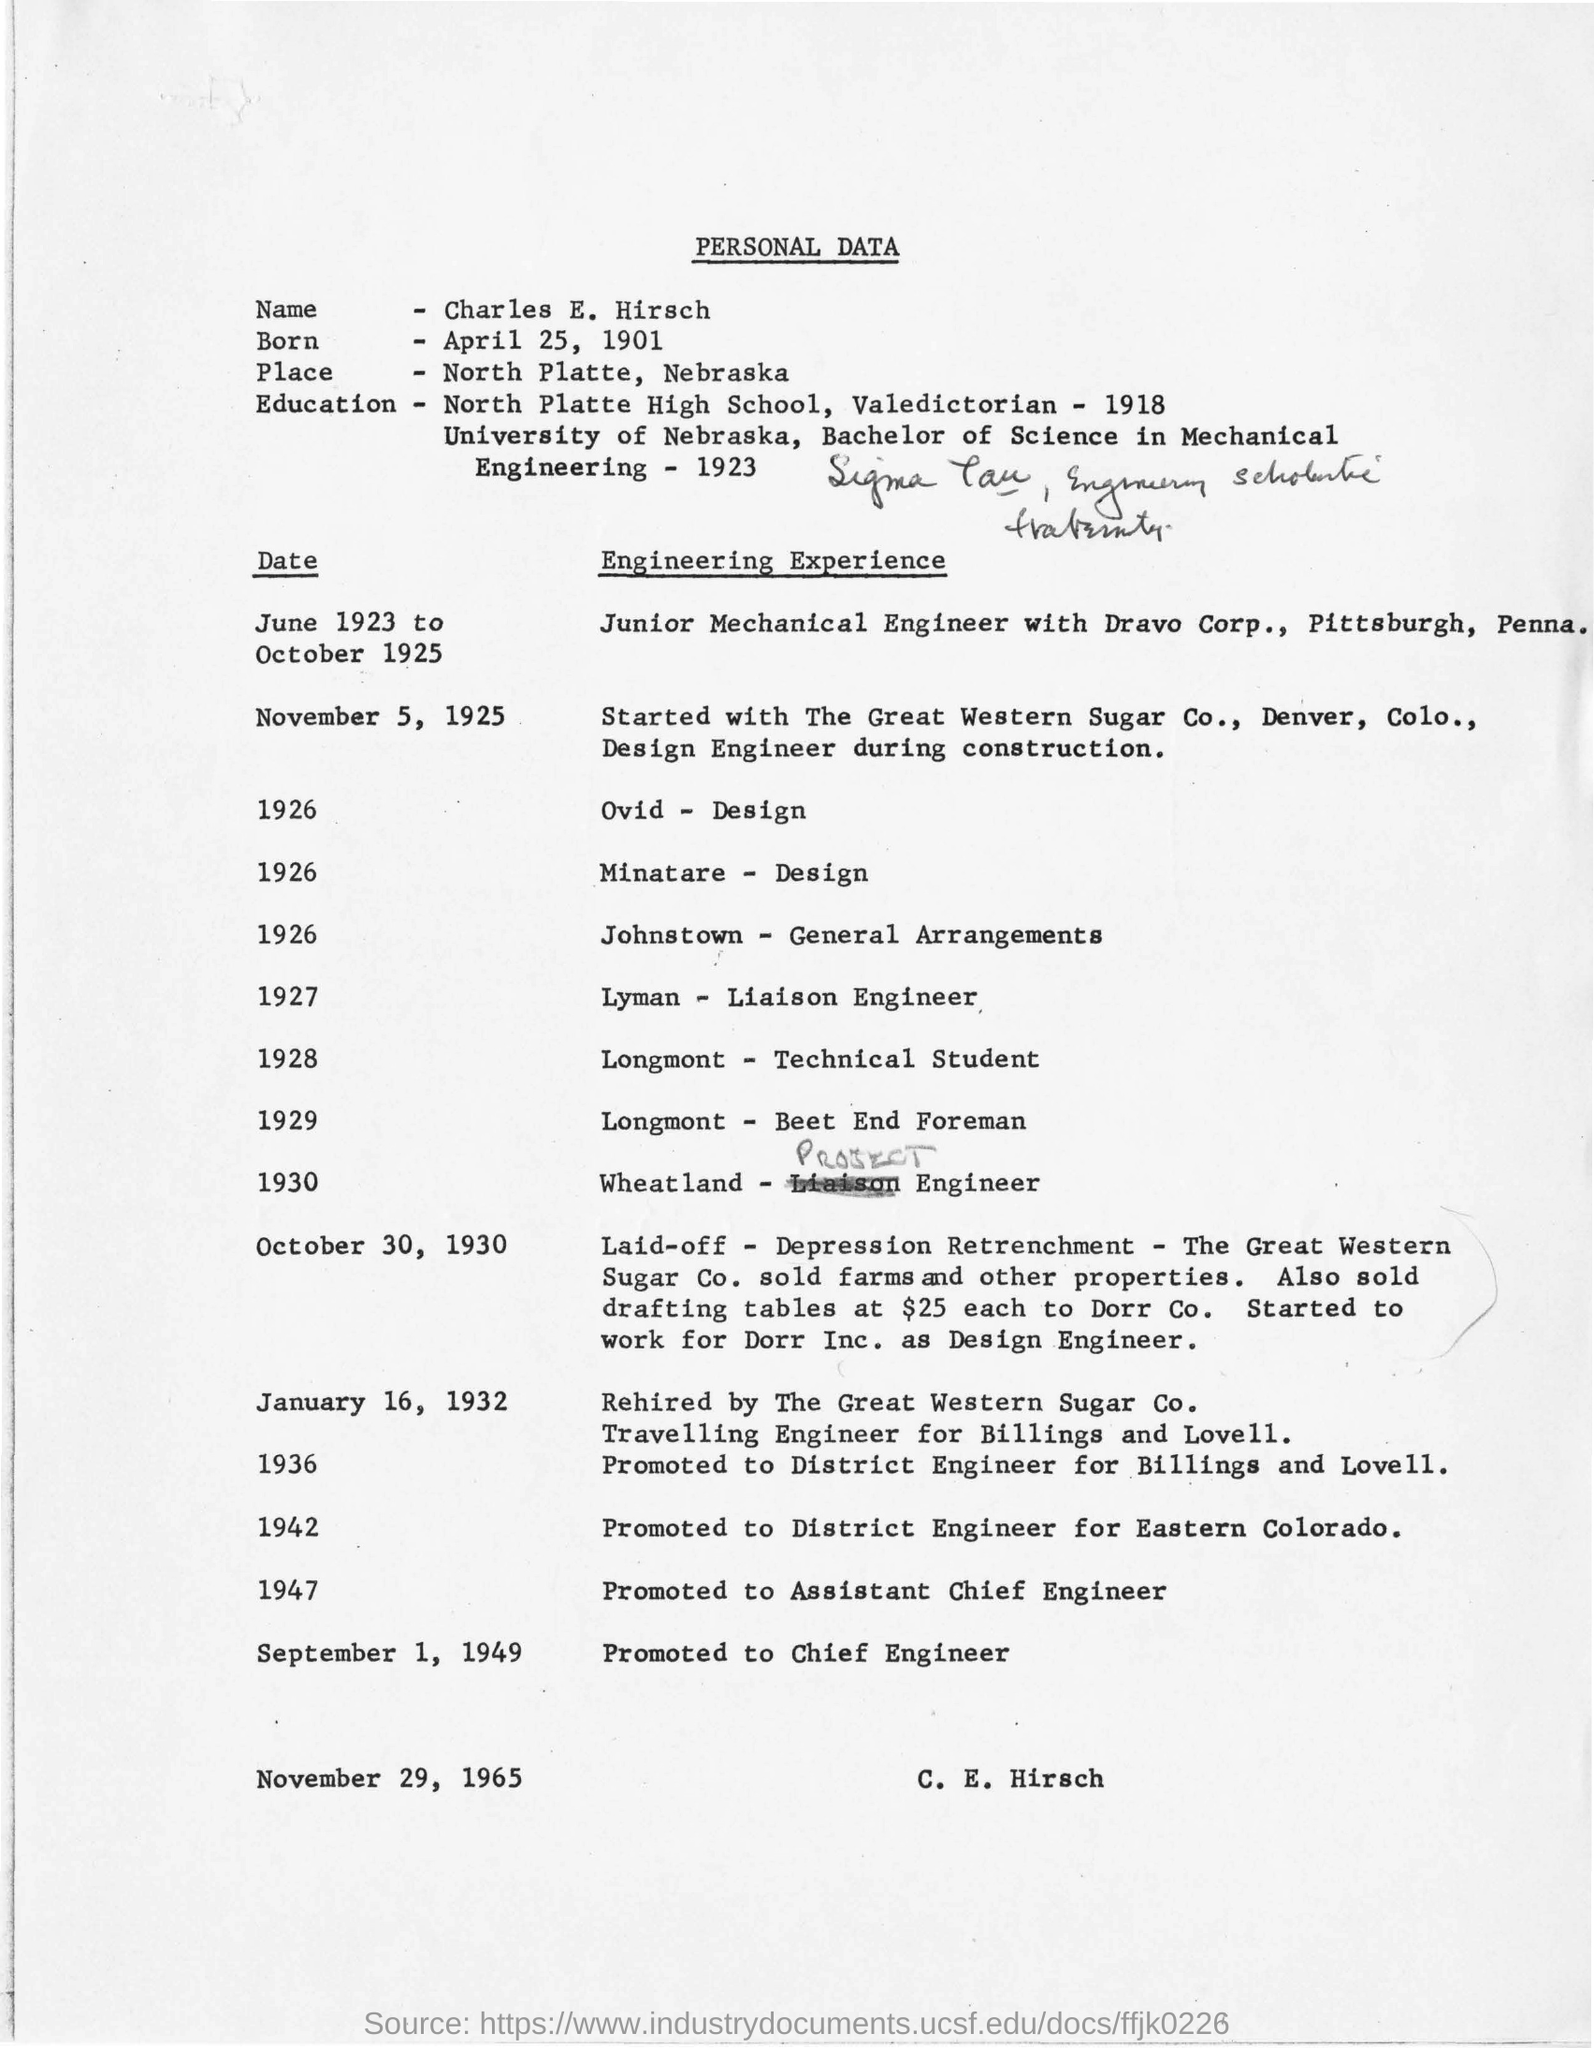Indicate a few pertinent items in this graphic. On September 1, 1949, Charles E. Hirsch was promoted to the position of Chief Engineer. Charles E. Hirsch was born on April 25, 1901. The personal data of Charles E. Hirsch is presented. 